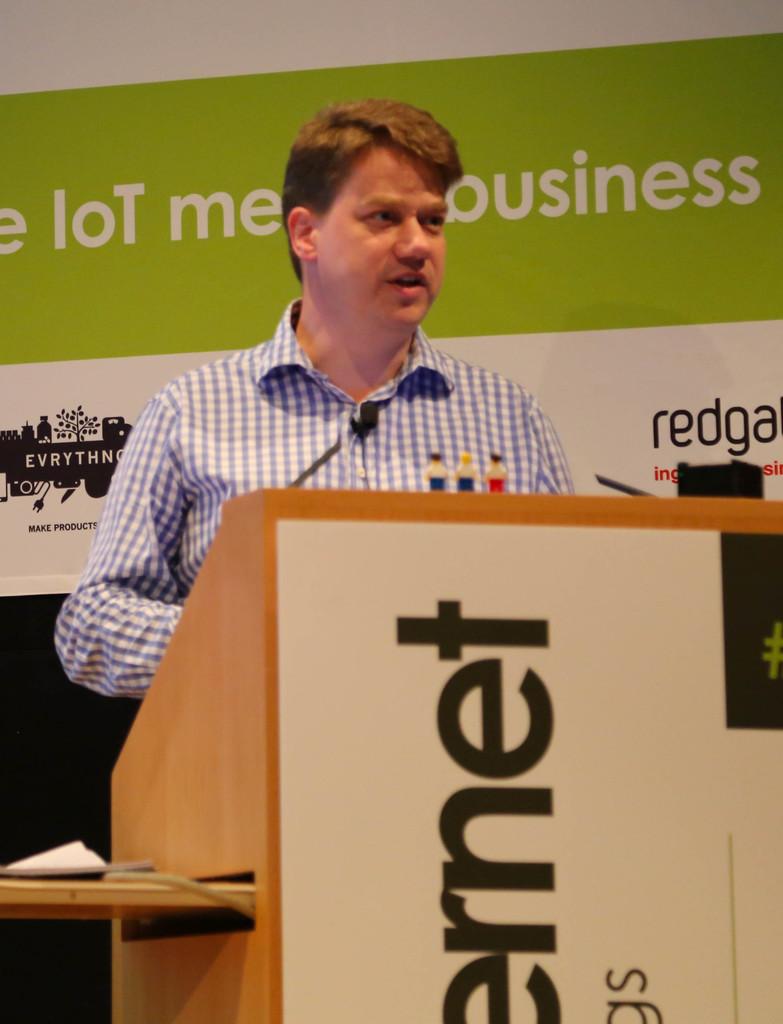What is the guy talking about?
Provide a short and direct response. Business. What is the last letter on the podium?
Offer a terse response. T. 